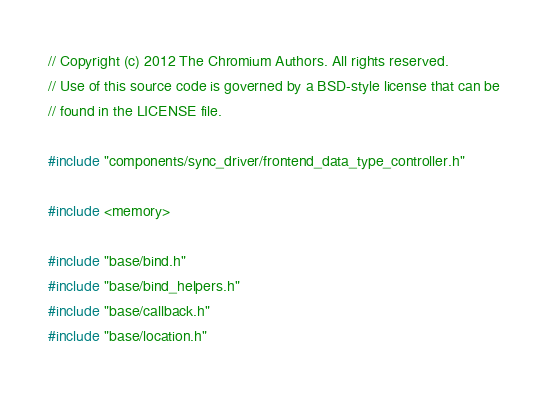Convert code to text. <code><loc_0><loc_0><loc_500><loc_500><_C++_>// Copyright (c) 2012 The Chromium Authors. All rights reserved.
// Use of this source code is governed by a BSD-style license that can be
// found in the LICENSE file.

#include "components/sync_driver/frontend_data_type_controller.h"

#include <memory>

#include "base/bind.h"
#include "base/bind_helpers.h"
#include "base/callback.h"
#include "base/location.h"</code> 